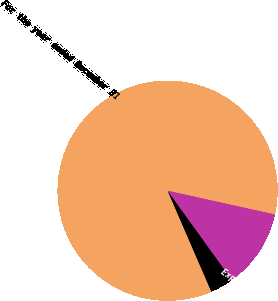<chart> <loc_0><loc_0><loc_500><loc_500><pie_chart><fcel>For the year ended December 31<fcel>Interest cost on benefit<fcel>Expected return on plan assets<nl><fcel>84.98%<fcel>3.43%<fcel>11.59%<nl></chart> 